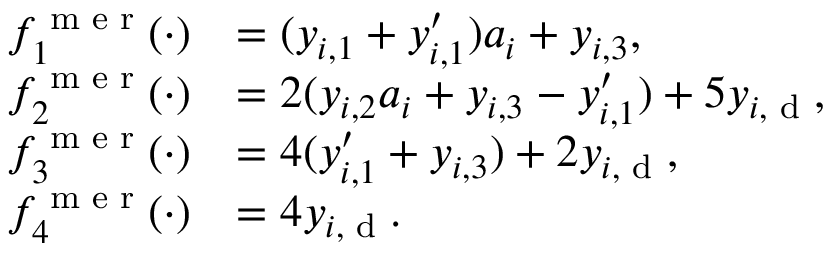Convert formula to latex. <formula><loc_0><loc_0><loc_500><loc_500>\begin{array} { r l } { f _ { 1 } ^ { m e r } ( \cdot ) } & { = ( y _ { i , 1 } + y _ { i , 1 } ^ { \prime } ) a _ { i } + y _ { i , 3 } , } \\ { f _ { 2 } ^ { m e r } ( \cdot ) } & { = 2 ( y _ { i , 2 } a _ { i } + y _ { i , 3 } - y _ { i , 1 } ^ { \prime } ) + 5 y _ { i , d } , } \\ { f _ { 3 } ^ { m e r } ( \cdot ) } & { = 4 ( y _ { i , 1 } ^ { \prime } + y _ { i , 3 } ) + 2 y _ { i , d } , } \\ { f _ { 4 } ^ { m e r } ( \cdot ) } & { = 4 y _ { i , d } . } \end{array}</formula> 